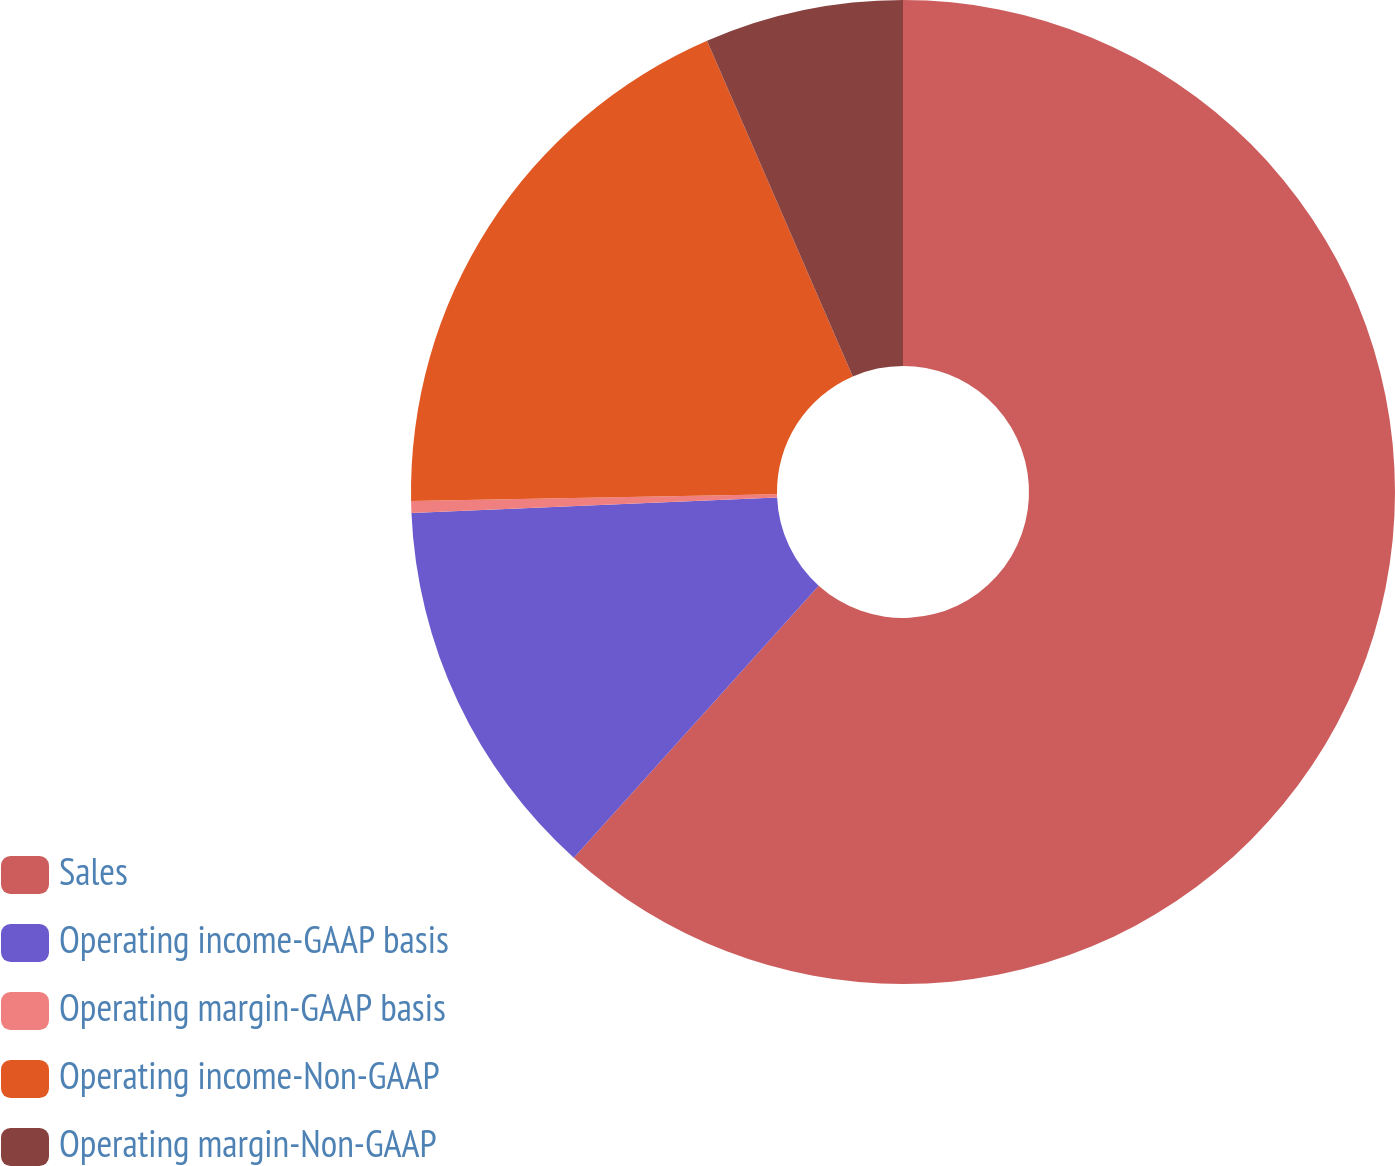Convert chart. <chart><loc_0><loc_0><loc_500><loc_500><pie_chart><fcel>Sales<fcel>Operating income-GAAP basis<fcel>Operating margin-GAAP basis<fcel>Operating income-Non-GAAP<fcel>Operating margin-Non-GAAP<nl><fcel>61.66%<fcel>12.65%<fcel>0.39%<fcel>18.77%<fcel>6.52%<nl></chart> 